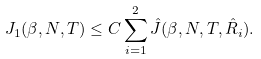Convert formula to latex. <formula><loc_0><loc_0><loc_500><loc_500>J _ { 1 } ( \beta , N , T ) \leq C \sum _ { i = 1 } ^ { 2 } \hat { J } ( \beta , N , T , \hat { R } _ { i } ) .</formula> 